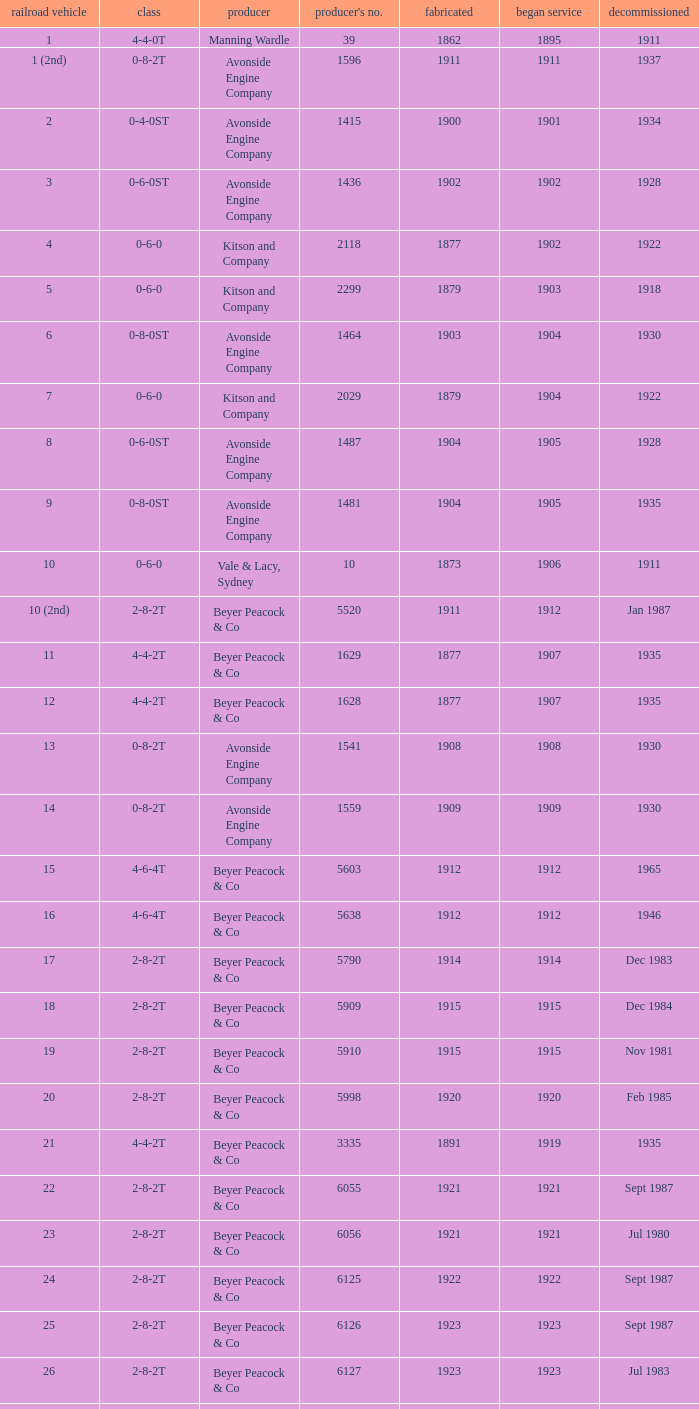Which locomotive had a 2-8-2t type, entered service year prior to 1915, and which was built after 1911? 17.0. 